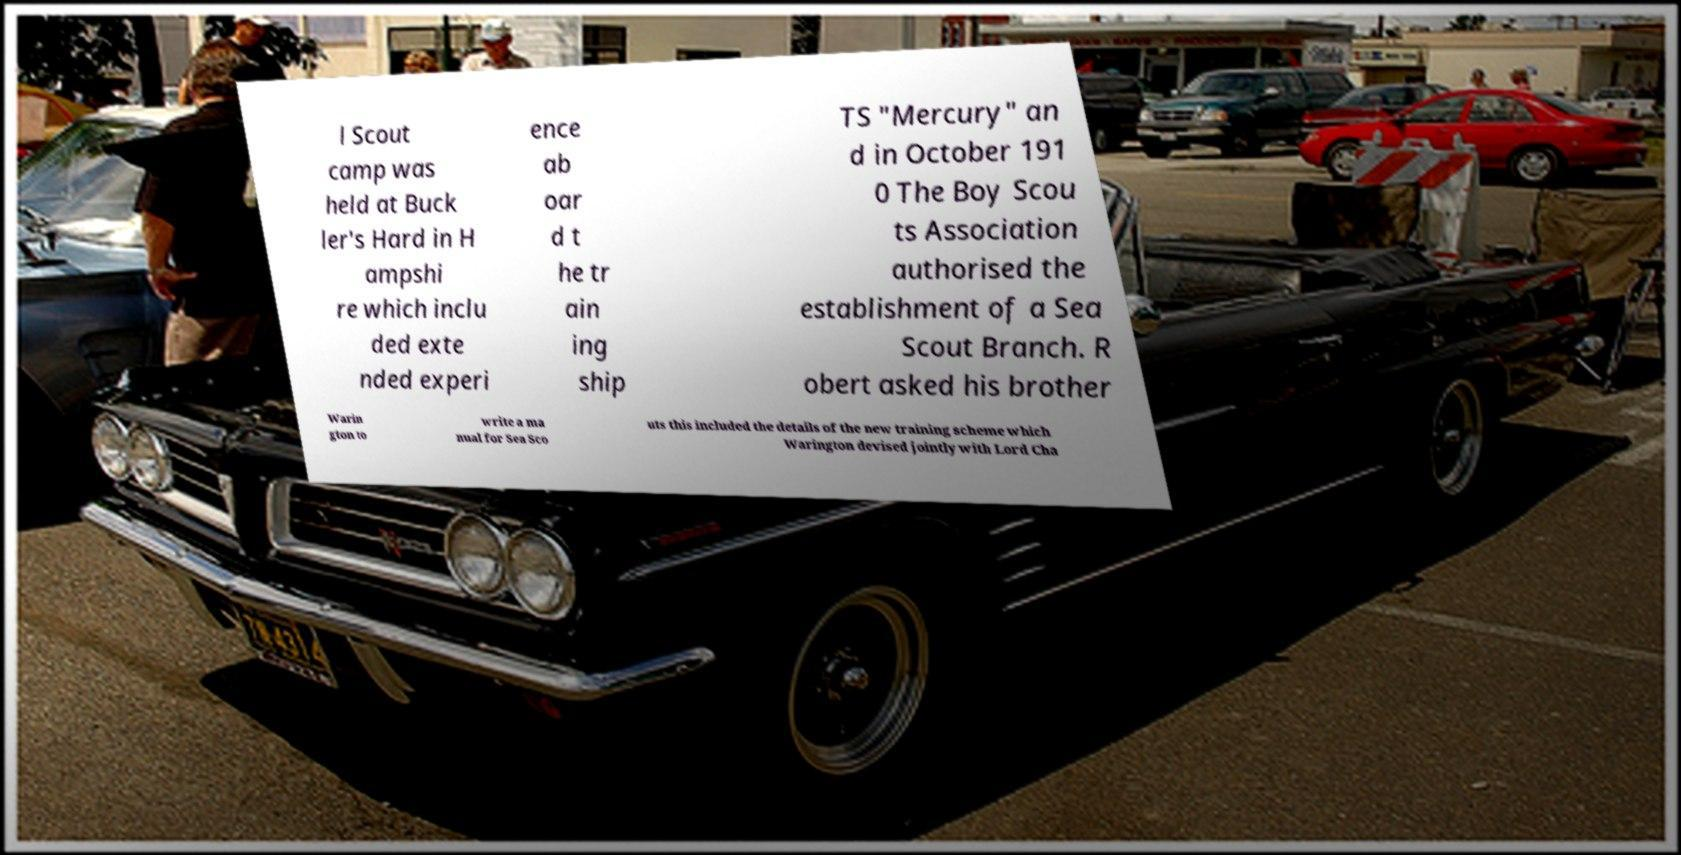Please identify and transcribe the text found in this image. l Scout camp was held at Buck ler's Hard in H ampshi re which inclu ded exte nded experi ence ab oar d t he tr ain ing ship TS "Mercury" an d in October 191 0 The Boy Scou ts Association authorised the establishment of a Sea Scout Branch. R obert asked his brother Warin gton to write a ma nual for Sea Sco uts this included the details of the new training scheme which Warington devised jointly with Lord Cha 